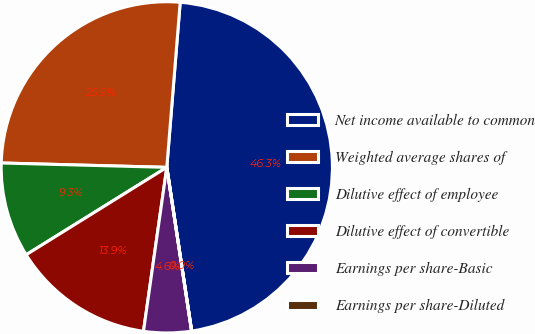Convert chart to OTSL. <chart><loc_0><loc_0><loc_500><loc_500><pie_chart><fcel>Net income available to common<fcel>Weighted average shares of<fcel>Dilutive effect of employee<fcel>Dilutive effect of convertible<fcel>Earnings per share-Basic<fcel>Earnings per share-Diluted<nl><fcel>46.31%<fcel>25.87%<fcel>9.27%<fcel>13.9%<fcel>4.64%<fcel>0.01%<nl></chart> 